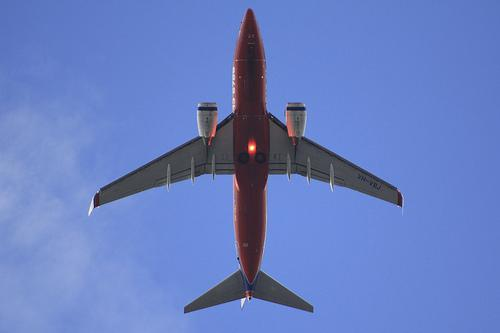Question: how many planes are there?
Choices:
A. Two.
B. One.
C. Three.
D. Four.
Answer with the letter. Answer: B Question: when is it?
Choices:
A. Winter.
B. April.
C. During the day.
D. Night.
Answer with the letter. Answer: C Question: why is the plane in the sky?
Choices:
A. Flying a banner.
B. It is flying.
C. Transporting people.
D. Going to Boston.
Answer with the letter. Answer: B 